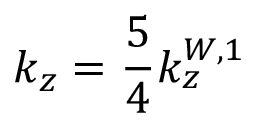<formula> <loc_0><loc_0><loc_500><loc_500>k _ { z } = \frac { 5 } { 4 } k _ { z } ^ { W , 1 }</formula> 